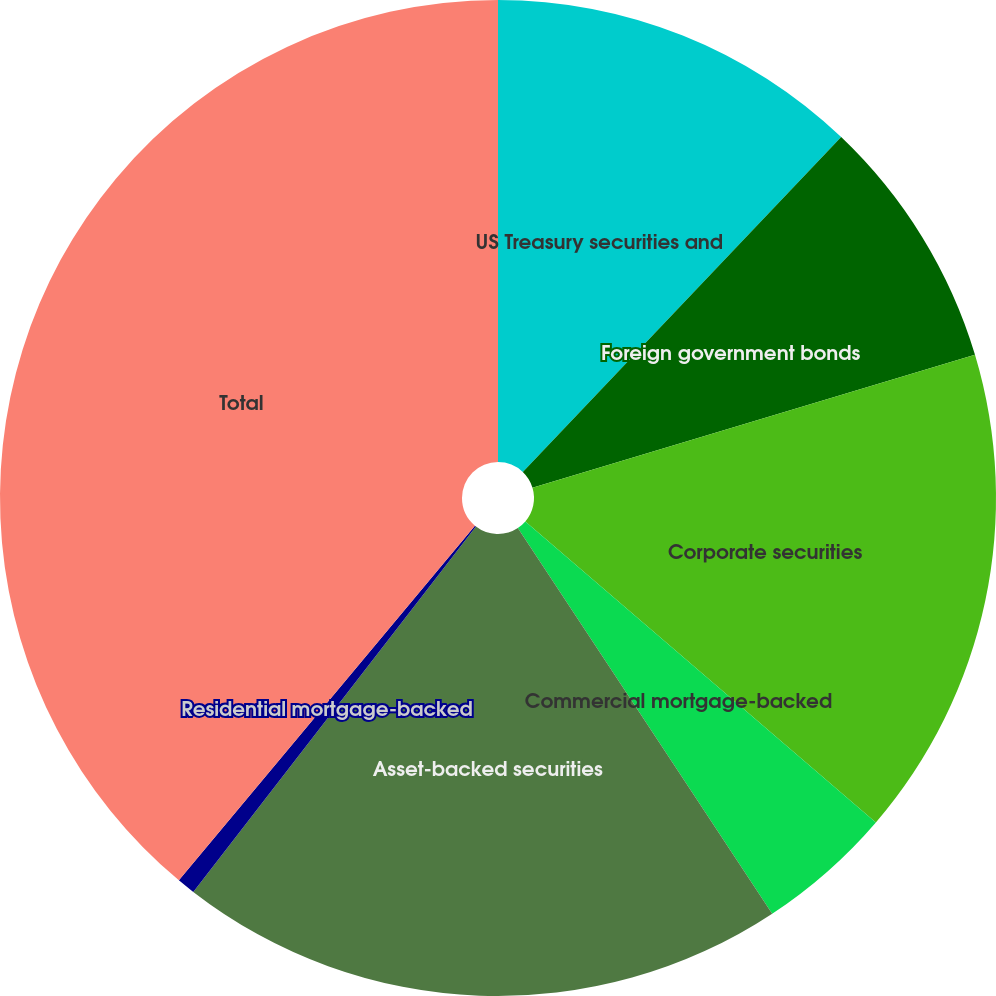Convert chart to OTSL. <chart><loc_0><loc_0><loc_500><loc_500><pie_chart><fcel>US Treasury securities and<fcel>Foreign government bonds<fcel>Corporate securities<fcel>Commercial mortgage-backed<fcel>Asset-backed securities<fcel>Residential mortgage-backed<fcel>Total<nl><fcel>12.1%<fcel>8.26%<fcel>15.93%<fcel>4.43%<fcel>19.76%<fcel>0.59%<fcel>38.93%<nl></chart> 